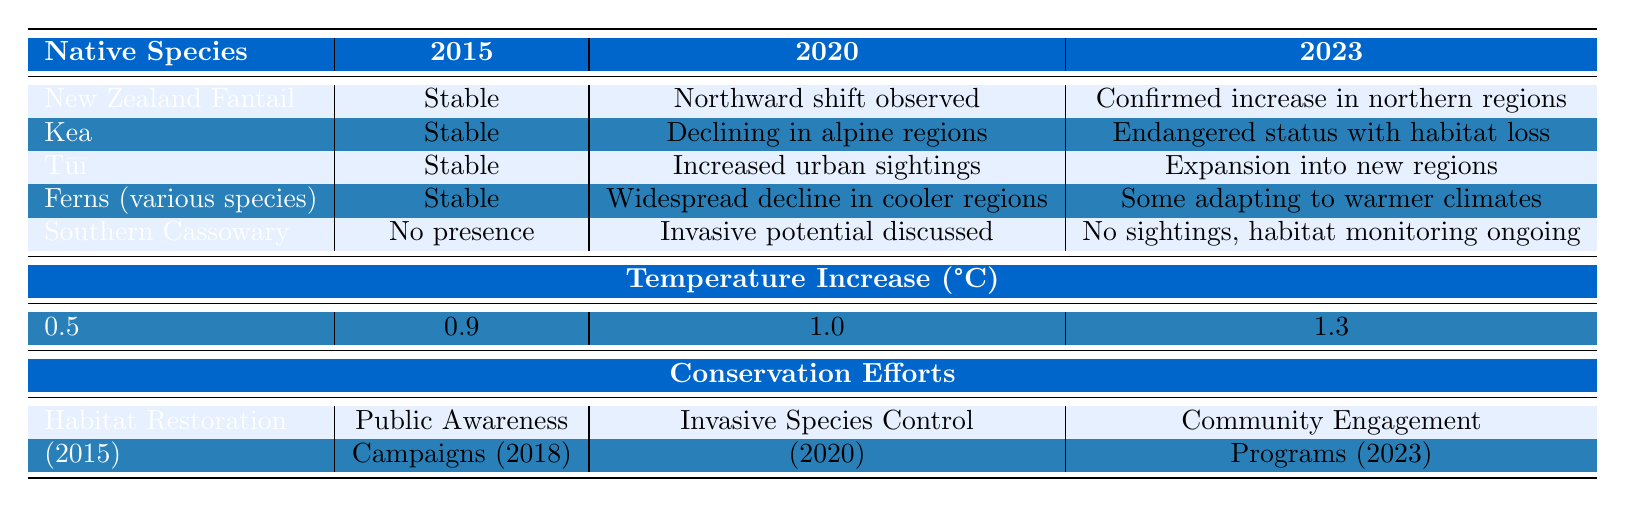What was the temperature increase in 2022? According to the table under the "Temperature Increase (°C)" section, the value for the year 2022 is 1.2°C.
Answer: 1.2°C How many species showed a stable distribution in 2015? The table lists five native species, out of which four have "Stable" as their distribution change in 2015: New Zealand Fantail, Kea, Tūī, and Ferns.
Answer: 4 species What conservation effort was initiated in 2015? The table indicates that in 2015, the conservation effort for "Habitat Restoration" was initiated.
Answer: Habitat Restoration What is the trend in distribution for Tūī from 2015 to 2023? Tūī maintained a "Stable" distribution in 2015, saw "Increased sightings in urban areas" by 2020, and then had "Expansion into previously uninhabited regions" by 2023, indicating a positive trend in distribution.
Answer: Positive trend Which species is listed as endangered in 2023? The Kea is mentioned in the table with "Endangered status with habitat loss" in 2023.
Answer: Kea What is the difference in temperature increase from 2015 to 2023? The temperature increase in 2015 was 0.5°C and in 2023 it was 1.3°C; therefore, the difference is 1.3 - 0.5 = 0.8°C.
Answer: 0.8°C Did any of the native species experience population declines from 2015 to 2023? Yes, the Kea experienced declining populations in alpine regions from 2020 and was noted as endangered in 2023, which indicates a decline.
Answer: Yes What were the conservation initiatives from 2015 to 2023? The table lists: Habitat Restoration (2015), Public Awareness Campaigns (2018), Invasive Species Control (2020), Climate Resilience Planning (2022), and Community Engagement Programs (2023).
Answer: Five initiatives Which native species showed changes in distribution towards northern regions? The New Zealand Fantail showed a "Northward shift observed" in 2020 and a "Confirmed increase in numbers in northern regions" in 2023.
Answer: New Zealand Fantail How many unique conservation efforts were recorded during the time period? There are five unique conservation efforts mentioned in the table: Habitat Restoration, Public Awareness Campaigns, Invasive Species Control, Climate Resilience Planning, and Community Engagement Programs.
Answer: 5 unique efforts 